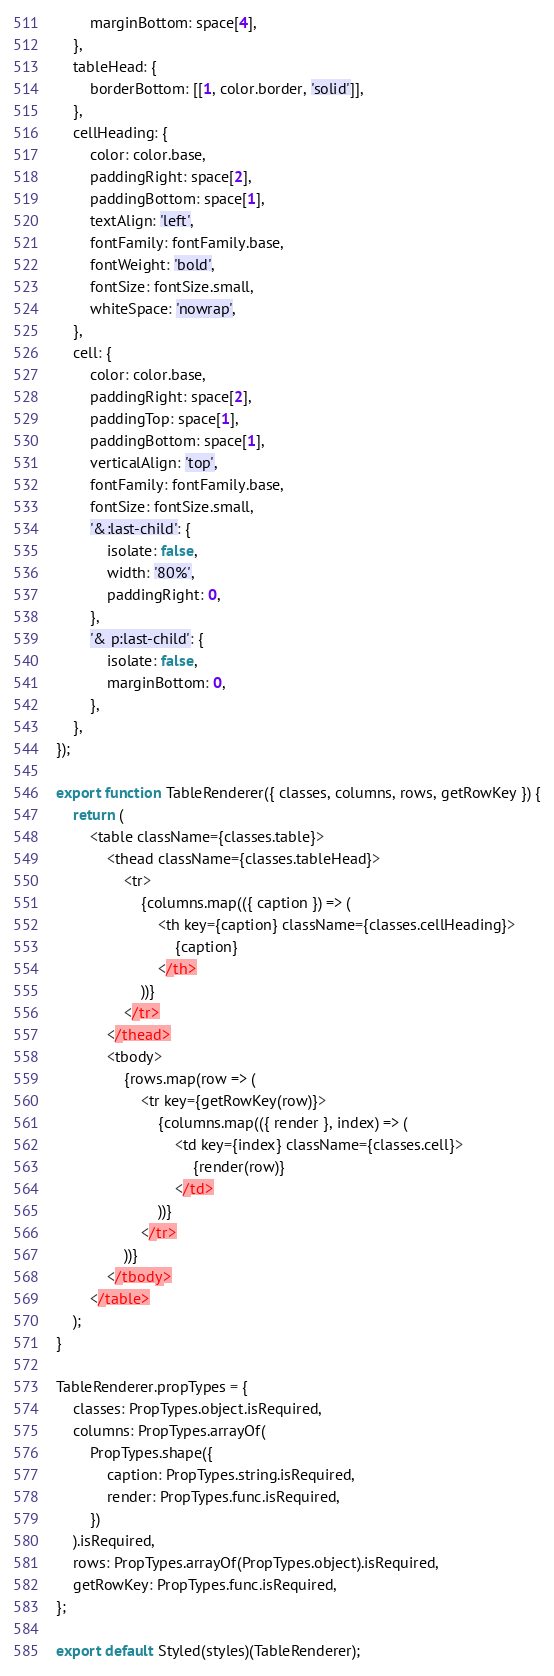<code> <loc_0><loc_0><loc_500><loc_500><_JavaScript_>		marginBottom: space[4],
	},
	tableHead: {
		borderBottom: [[1, color.border, 'solid']],
	},
	cellHeading: {
		color: color.base,
		paddingRight: space[2],
		paddingBottom: space[1],
		textAlign: 'left',
		fontFamily: fontFamily.base,
		fontWeight: 'bold',
		fontSize: fontSize.small,
		whiteSpace: 'nowrap',
	},
	cell: {
		color: color.base,
		paddingRight: space[2],
		paddingTop: space[1],
		paddingBottom: space[1],
		verticalAlign: 'top',
		fontFamily: fontFamily.base,
		fontSize: fontSize.small,
		'&:last-child': {
			isolate: false,
			width: '80%',
			paddingRight: 0,
		},
		'& p:last-child': {
			isolate: false,
			marginBottom: 0,
		},
	},
});

export function TableRenderer({ classes, columns, rows, getRowKey }) {
	return (
		<table className={classes.table}>
			<thead className={classes.tableHead}>
				<tr>
					{columns.map(({ caption }) => (
						<th key={caption} className={classes.cellHeading}>
							{caption}
						</th>
					))}
				</tr>
			</thead>
			<tbody>
				{rows.map(row => (
					<tr key={getRowKey(row)}>
						{columns.map(({ render }, index) => (
							<td key={index} className={classes.cell}>
								{render(row)}
							</td>
						))}
					</tr>
				))}
			</tbody>
		</table>
	);
}

TableRenderer.propTypes = {
	classes: PropTypes.object.isRequired,
	columns: PropTypes.arrayOf(
		PropTypes.shape({
			caption: PropTypes.string.isRequired,
			render: PropTypes.func.isRequired,
		})
	).isRequired,
	rows: PropTypes.arrayOf(PropTypes.object).isRequired,
	getRowKey: PropTypes.func.isRequired,
};

export default Styled(styles)(TableRenderer);
</code> 